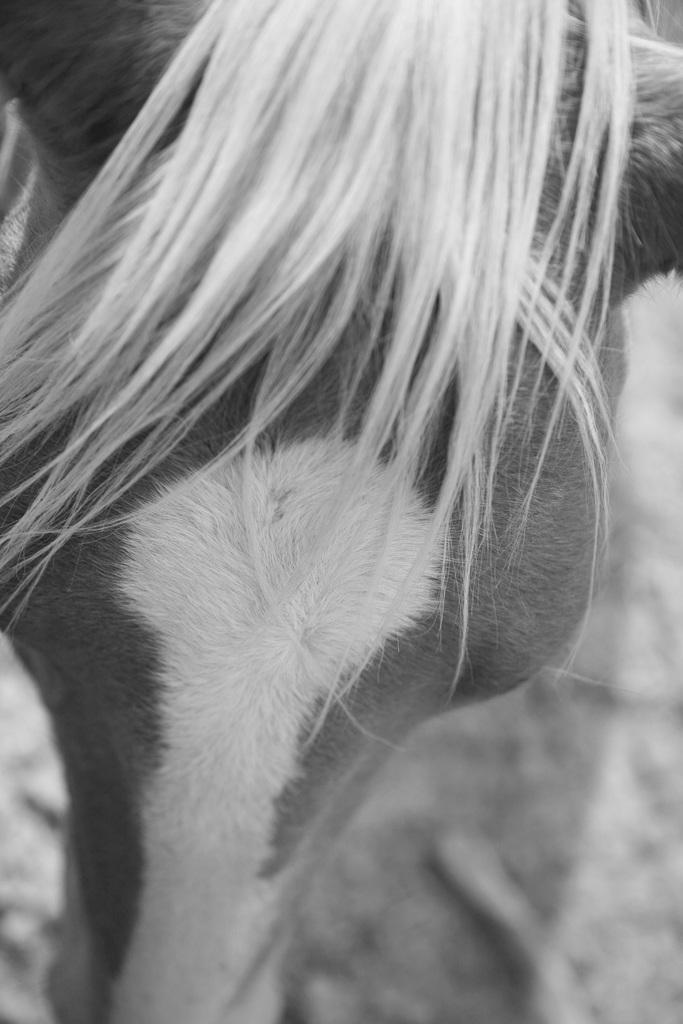How would you summarize this image in a sentence or two? In this image I can see an animal on the ground. I can see the hair of the animal. The image is in black and white color. 